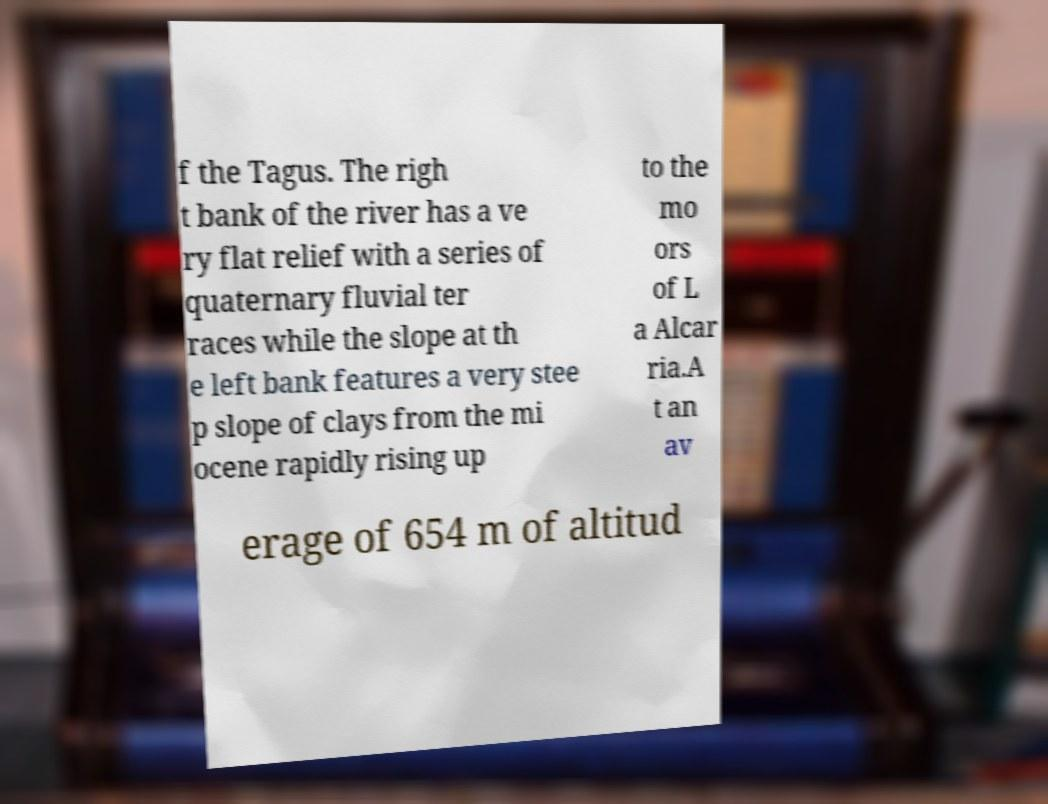There's text embedded in this image that I need extracted. Can you transcribe it verbatim? f the Tagus. The righ t bank of the river has a ve ry flat relief with a series of quaternary fluvial ter races while the slope at th e left bank features a very stee p slope of clays from the mi ocene rapidly rising up to the mo ors of L a Alcar ria.A t an av erage of 654 m of altitud 